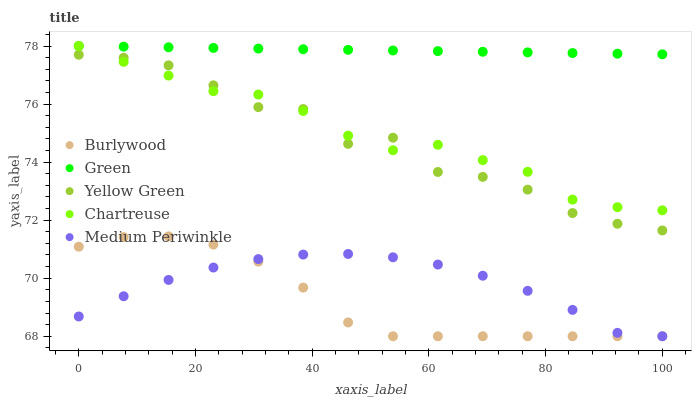Does Burlywood have the minimum area under the curve?
Answer yes or no. Yes. Does Green have the maximum area under the curve?
Answer yes or no. Yes. Does Medium Periwinkle have the minimum area under the curve?
Answer yes or no. No. Does Medium Periwinkle have the maximum area under the curve?
Answer yes or no. No. Is Green the smoothest?
Answer yes or no. Yes. Is Yellow Green the roughest?
Answer yes or no. Yes. Is Medium Periwinkle the smoothest?
Answer yes or no. No. Is Medium Periwinkle the roughest?
Answer yes or no. No. Does Burlywood have the lowest value?
Answer yes or no. Yes. Does Chartreuse have the lowest value?
Answer yes or no. No. Does Green have the highest value?
Answer yes or no. Yes. Does Medium Periwinkle have the highest value?
Answer yes or no. No. Is Medium Periwinkle less than Chartreuse?
Answer yes or no. Yes. Is Yellow Green greater than Burlywood?
Answer yes or no. Yes. Does Medium Periwinkle intersect Burlywood?
Answer yes or no. Yes. Is Medium Periwinkle less than Burlywood?
Answer yes or no. No. Is Medium Periwinkle greater than Burlywood?
Answer yes or no. No. Does Medium Periwinkle intersect Chartreuse?
Answer yes or no. No. 